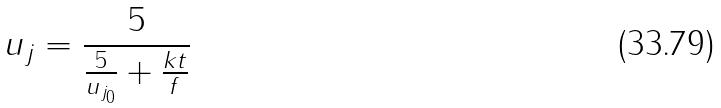<formula> <loc_0><loc_0><loc_500><loc_500>u _ { j } = \frac { 5 } { \frac { 5 } { u _ { j _ { 0 } } } + \frac { k t } { f } }</formula> 